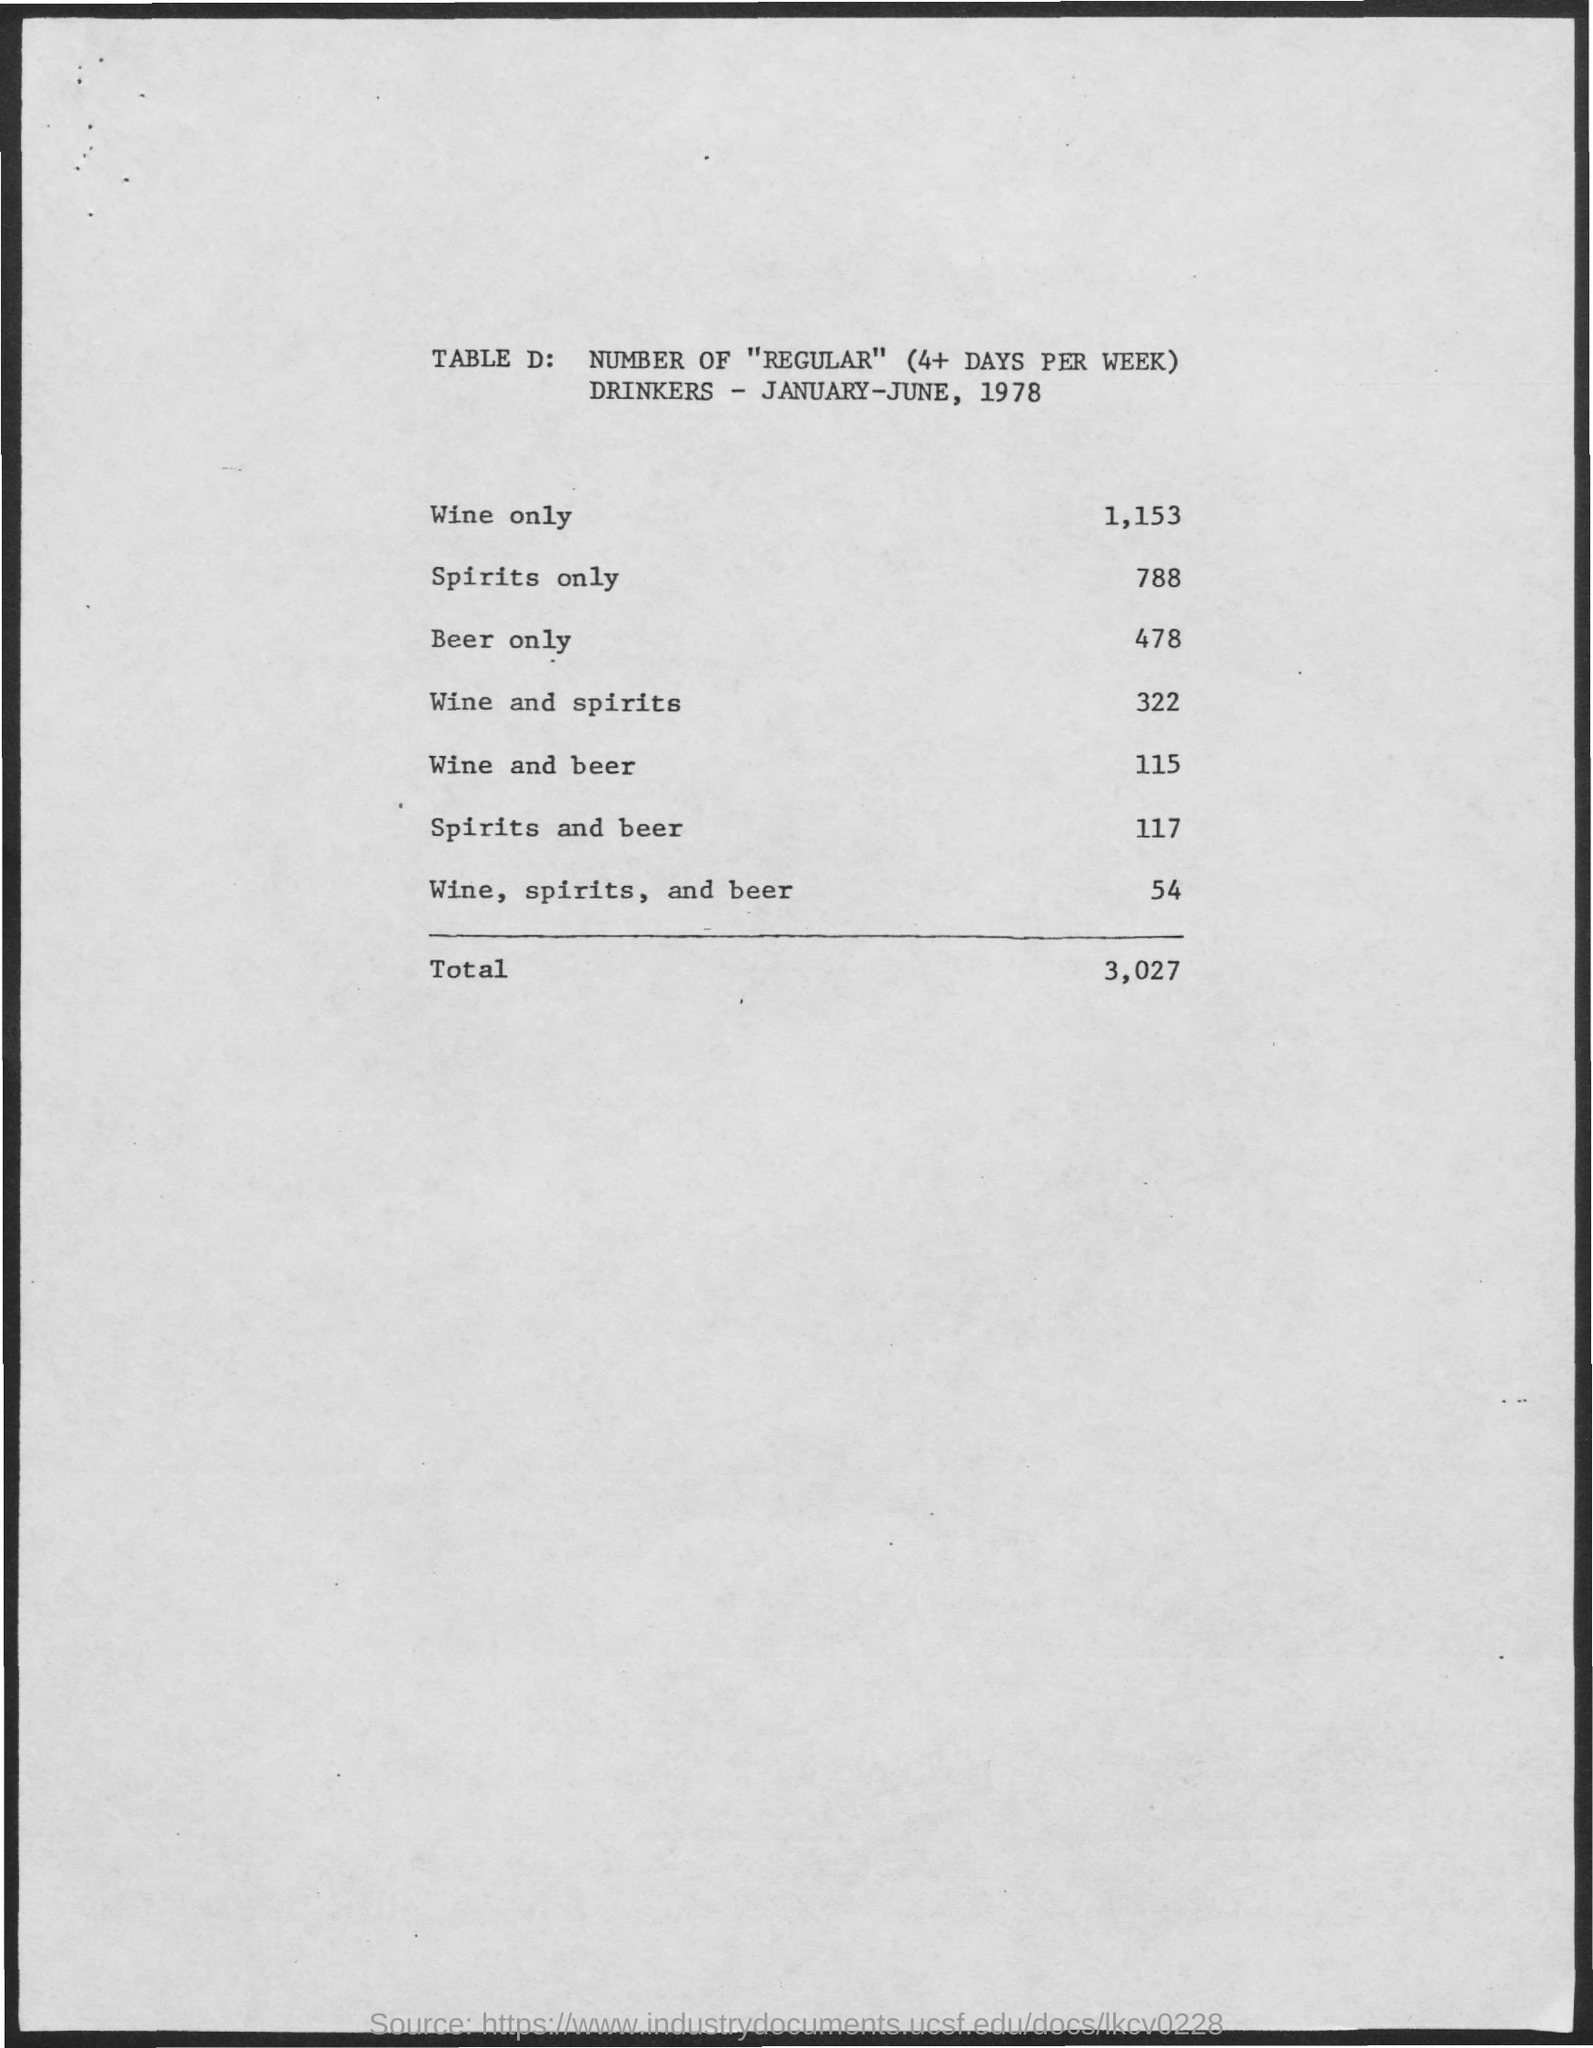What is the amount of total drinkers mentioned ?
Give a very brief answer. 3,027. What is the number of regular drinkers who drink wine only ?
Give a very brief answer. 1,153. What is the number of drinkers who drink spirits only ?
Your answer should be very brief. 788. What is the number of drinkers who drink beer only ?
Your answer should be very brief. 478. What is the number of drinkers who drink wine and spirits ?
Offer a very short reply. 322. What is the number of drinkers who drink wine and beer ?
Your response must be concise. 115. What is the number of drinkers who drink spirits and beer ?
Offer a very short reply. 117. What is the number of drinkers who drink wine, spirits and beer ?
Offer a very short reply. 54. 